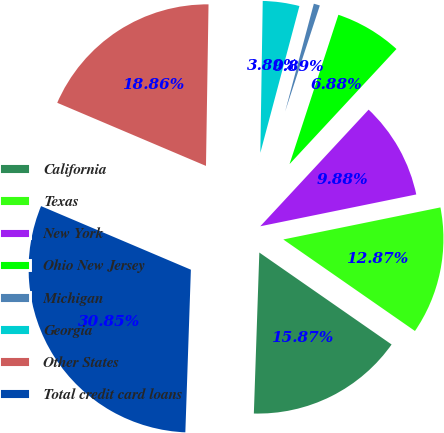Convert chart to OTSL. <chart><loc_0><loc_0><loc_500><loc_500><pie_chart><fcel>California<fcel>Texas<fcel>New York<fcel>Ohio New Jersey<fcel>Michigan<fcel>Georgia<fcel>Other States<fcel>Total credit card loans<nl><fcel>15.87%<fcel>12.87%<fcel>9.88%<fcel>6.88%<fcel>0.89%<fcel>3.89%<fcel>18.86%<fcel>30.84%<nl></chart> 